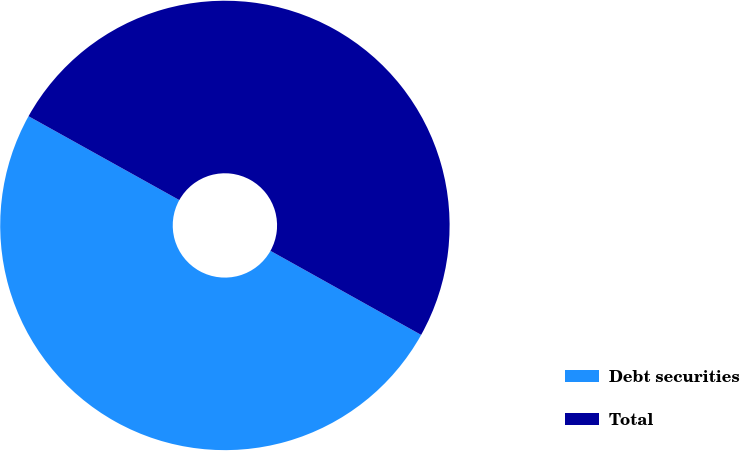Convert chart to OTSL. <chart><loc_0><loc_0><loc_500><loc_500><pie_chart><fcel>Debt securities<fcel>Total<nl><fcel>49.98%<fcel>50.02%<nl></chart> 